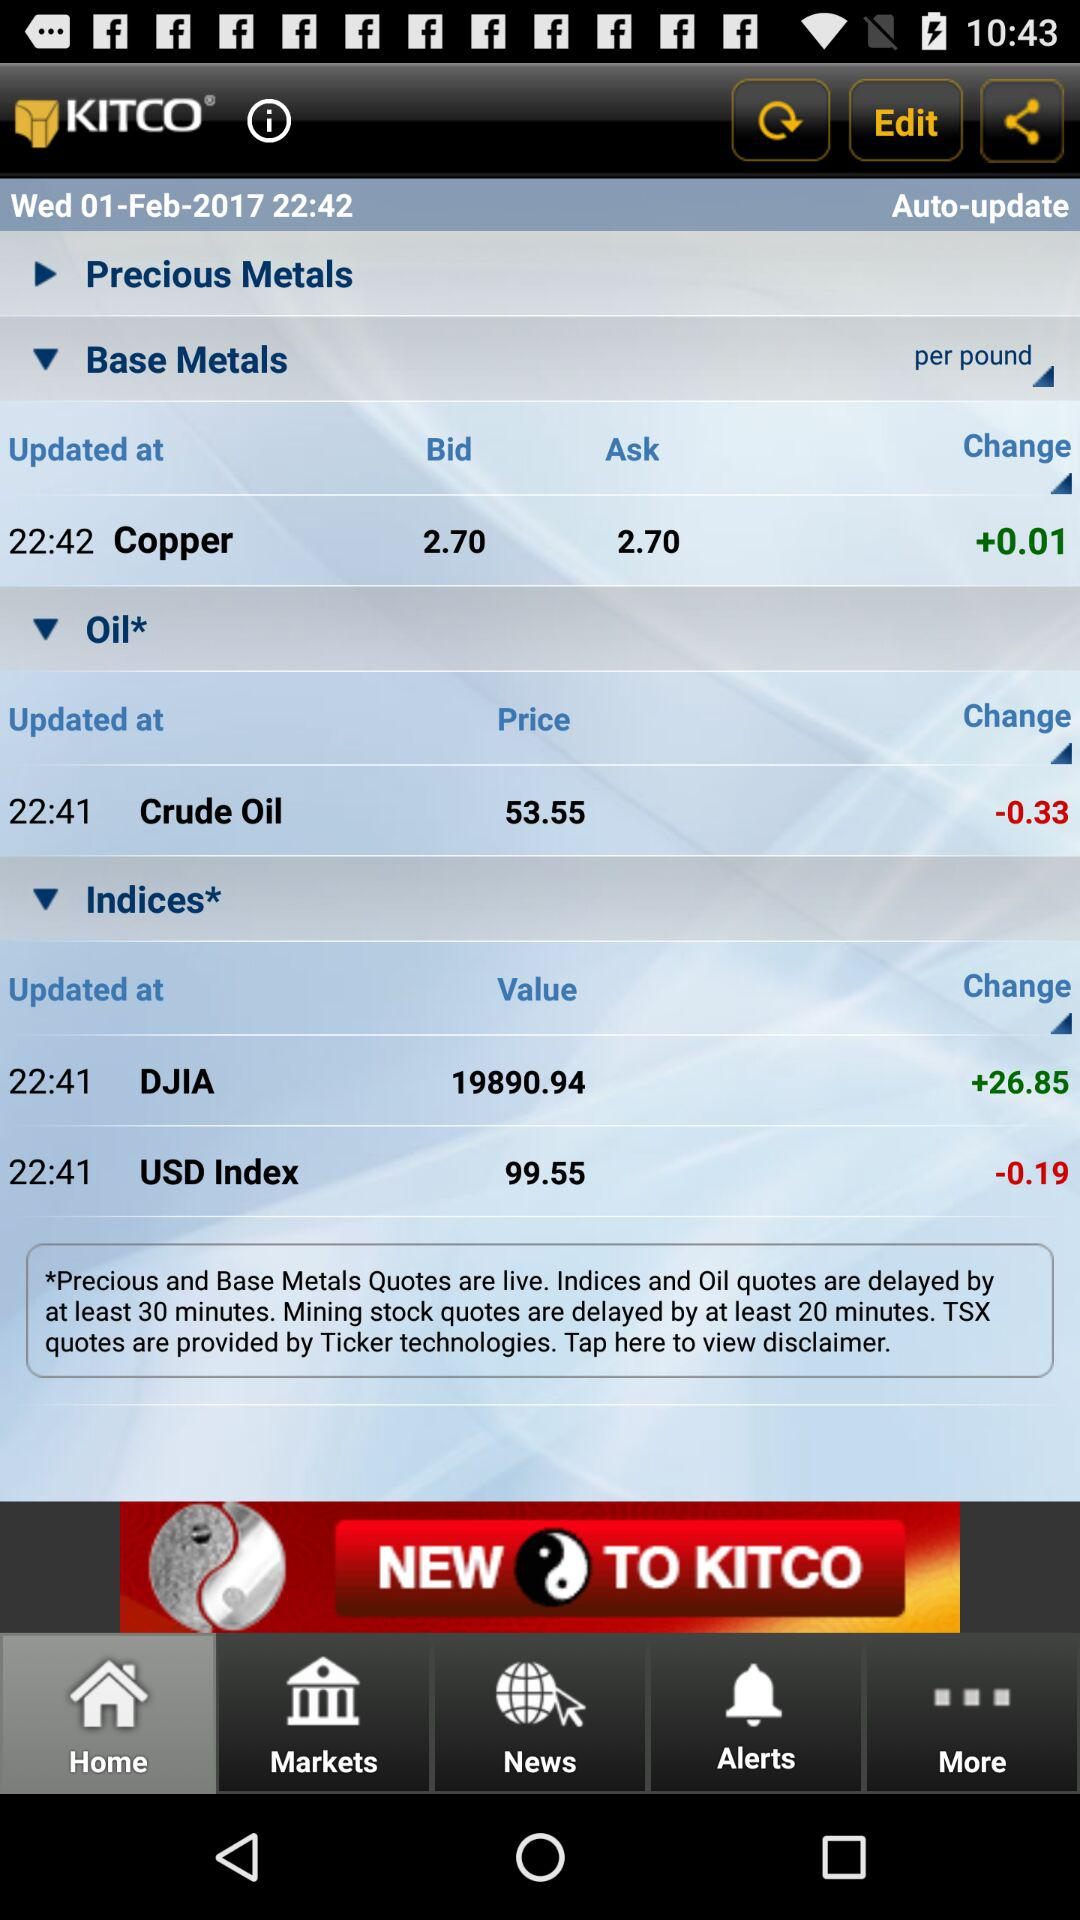What is the difference in value between the current price of USD Index and the previous price?
Answer the question using a single word or phrase. -0.19 